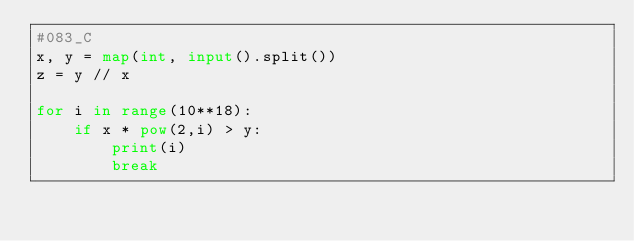<code> <loc_0><loc_0><loc_500><loc_500><_Python_>#083_C
x, y = map(int, input().split())
z = y // x

for i in range(10**18):
    if x * pow(2,i) > y:
        print(i)
        break</code> 